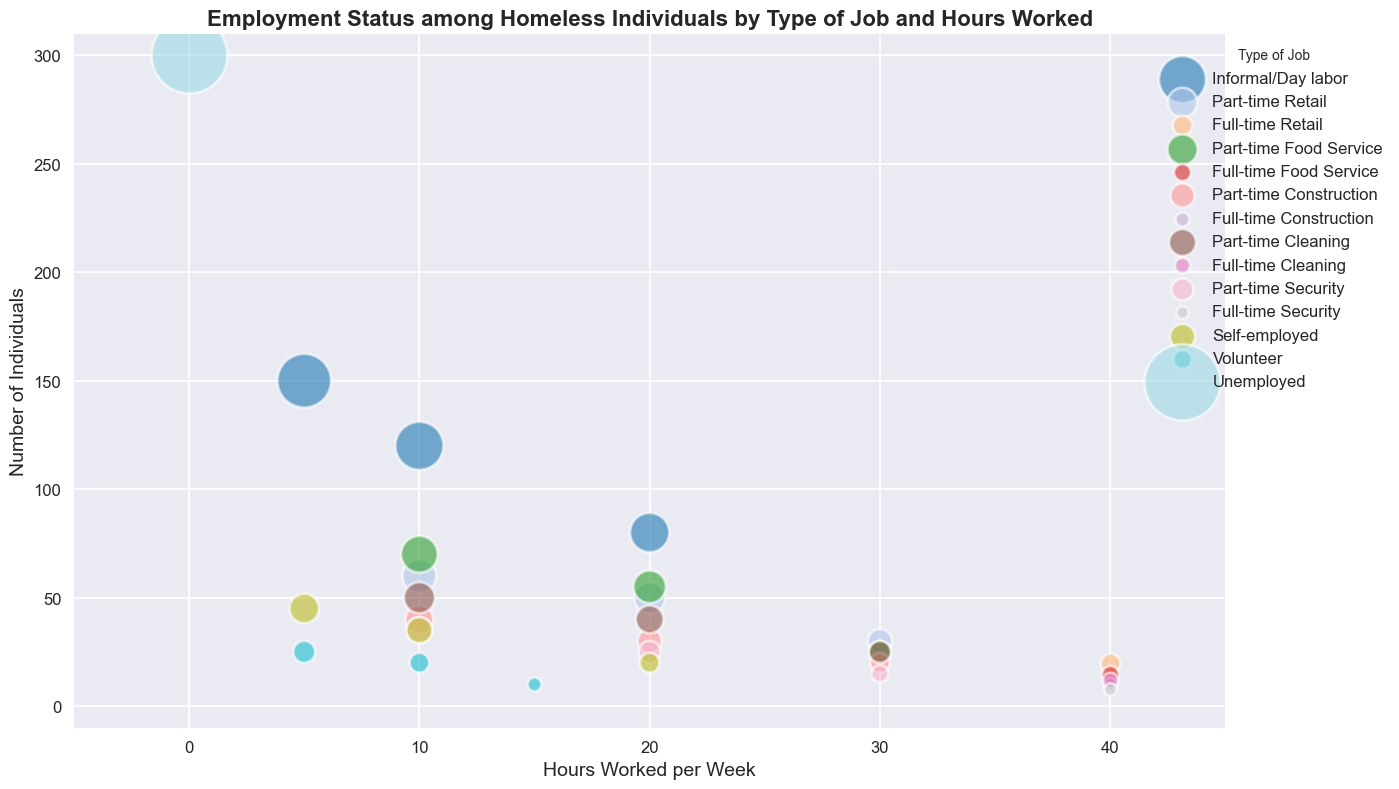Which job type has the smallest bubble for 5 hours per week? Find the smallest bubble at 5 hours per week. It corresponds to "Volunteer."
Answer: Volunteer What is the numerical difference between individuals working 30 hours in Food Service and 30 hours in Construction? Locate 30-hour bubbles for "Food Service" and "Construction" then subtract their sizes: 25 (Food Service) - 20 (Construction) = 5.
Answer: 5 Which color bubble represents "Self-employed"? Identify the bubbles marked as "Self-employed" and note their color, which is typically distinct.
Answer: Blueish tone (depending on color scheme used) How does the number of individuals working 10 hours in Security compare to those working 10 hours in Part-time Retail? Compare the 10-hour bubbles for Security and Part-time Retail. The bubble for Security (35) is larger than that for Part-time Retail (60).
Answer: Fewer in Security What job type has individuals represented in both the lowest and highest hour categories? Identify a job type with bubbles both at the lowest working hour (5 hours) and the highest (40 hours). "Self-employed" fits this description as it has bubbles at both 5 and 40 hours.
Answer: Self-employed 